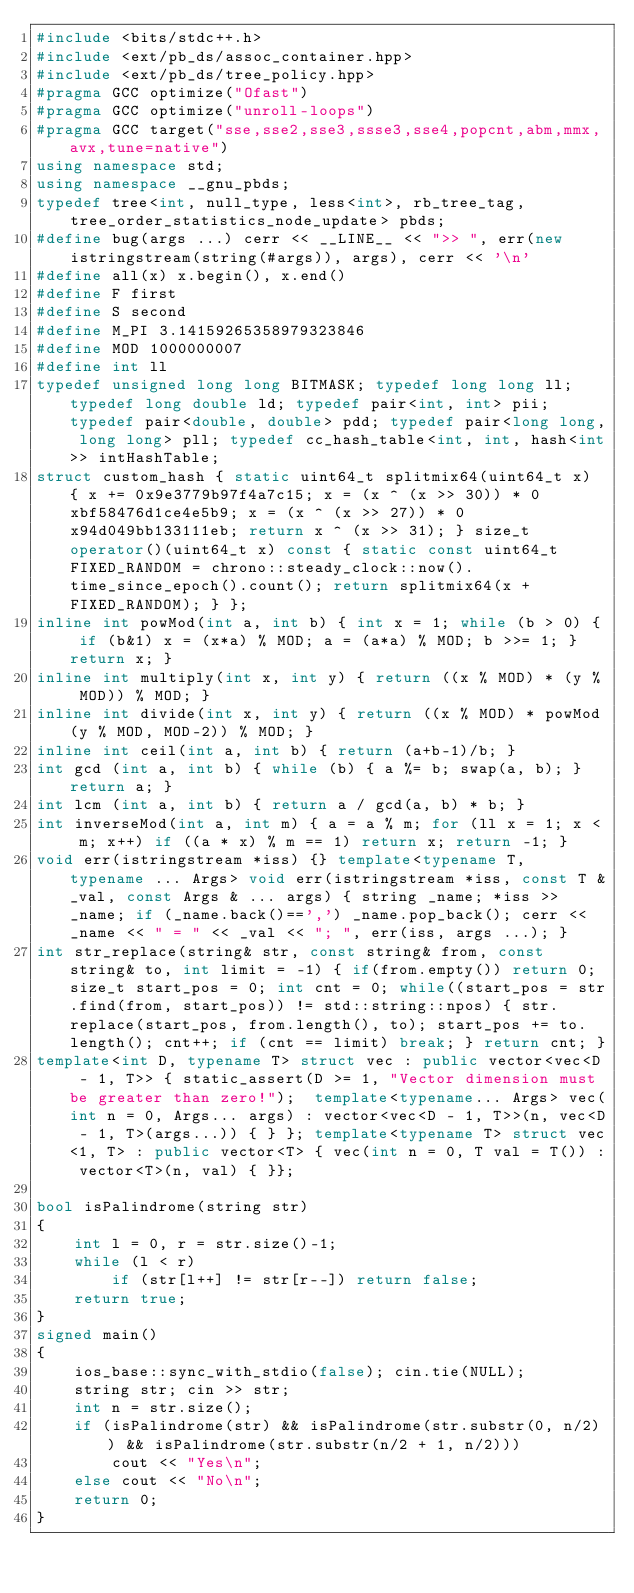<code> <loc_0><loc_0><loc_500><loc_500><_C++_>#include <bits/stdc++.h>
#include <ext/pb_ds/assoc_container.hpp>
#include <ext/pb_ds/tree_policy.hpp>
#pragma GCC optimize("Ofast")
#pragma GCC optimize("unroll-loops")
#pragma GCC target("sse,sse2,sse3,ssse3,sse4,popcnt,abm,mmx,avx,tune=native")
using namespace std;
using namespace __gnu_pbds;
typedef tree<int, null_type, less<int>, rb_tree_tag, tree_order_statistics_node_update> pbds;
#define bug(args ...) cerr << __LINE__ << ">> ", err(new istringstream(string(#args)), args), cerr << '\n'
#define all(x) x.begin(), x.end()
#define F first
#define S second
#define M_PI 3.14159265358979323846
#define MOD 1000000007
#define int ll
typedef unsigned long long BITMASK; typedef long long ll; typedef long double ld; typedef pair<int, int> pii; typedef pair<double, double> pdd; typedef pair<long long, long long> pll; typedef cc_hash_table<int, int, hash<int>> intHashTable;
struct custom_hash { static uint64_t splitmix64(uint64_t x) { x += 0x9e3779b97f4a7c15; x = (x ^ (x >> 30)) * 0xbf58476d1ce4e5b9; x = (x ^ (x >> 27)) * 0x94d049bb133111eb; return x ^ (x >> 31); } size_t operator()(uint64_t x) const { static const uint64_t FIXED_RANDOM = chrono::steady_clock::now().time_since_epoch().count(); return splitmix64(x + FIXED_RANDOM); } };
inline int powMod(int a, int b) { int x = 1; while (b > 0) { if (b&1) x = (x*a) % MOD; a = (a*a) % MOD; b >>= 1; } return x; }
inline int multiply(int x, int y) { return ((x % MOD) * (y % MOD)) % MOD; }
inline int divide(int x, int y) { return ((x % MOD) * powMod(y % MOD, MOD-2)) % MOD; }
inline int ceil(int a, int b) { return (a+b-1)/b; }
int gcd (int a, int b) { while (b) { a %= b; swap(a, b); } return a; }
int lcm (int a, int b) { return a / gcd(a, b) * b; }
int inverseMod(int a, int m) { a = a % m; for (ll x = 1; x < m; x++) if ((a * x) % m == 1) return x; return -1; }
void err(istringstream *iss) {} template<typename T, typename ... Args> void err(istringstream *iss, const T &_val, const Args & ... args) { string _name; *iss >> _name; if (_name.back()==',') _name.pop_back(); cerr << _name << " = " << _val << "; ", err(iss, args ...); }
int str_replace(string& str, const string& from, const string& to, int limit = -1) { if(from.empty()) return 0; size_t start_pos = 0; int cnt = 0; while((start_pos = str.find(from, start_pos)) != std::string::npos) { str.replace(start_pos, from.length(), to); start_pos += to.length(); cnt++; if (cnt == limit) break; } return cnt; }
template<int D, typename T> struct vec : public vector<vec<D - 1, T>> { static_assert(D >= 1, "Vector dimension must be greater than zero!");  template<typename... Args> vec(int n = 0, Args... args) : vector<vec<D - 1, T>>(n, vec<D - 1, T>(args...)) { } }; template<typename T> struct vec<1, T> : public vector<T> { vec(int n = 0, T val = T()) : vector<T>(n, val) { }};

bool isPalindrome(string str)
{
    int l = 0, r = str.size()-1;
    while (l < r)
        if (str[l++] != str[r--]) return false;
    return true;
}
signed main()
{
    ios_base::sync_with_stdio(false); cin.tie(NULL);
    string str; cin >> str;
    int n = str.size();
    if (isPalindrome(str) && isPalindrome(str.substr(0, n/2)) && isPalindrome(str.substr(n/2 + 1, n/2)))
        cout << "Yes\n";
    else cout << "No\n";
    return 0;
}</code> 